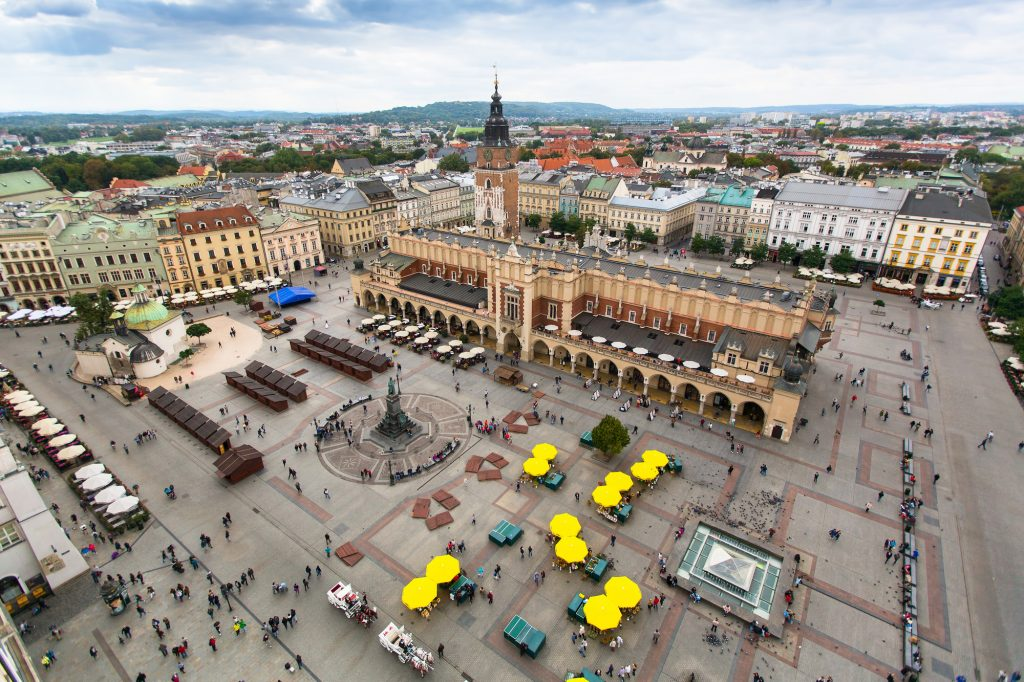What events take place in the Main Market Square today? Today, the Main Market Square is a vibrant hub of activity and culture in Krakow, hosting a variety of events throughout the year. These include traditional Christmas and Easter markets, vibrant outdoor cafes and live performances during the summer months, and numerous festivals and parades that reflect both local traditions and global influences. It's a place where modern life and historical context blend seamlessly, offering something for everyone to enjoy. 